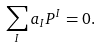Convert formula to latex. <formula><loc_0><loc_0><loc_500><loc_500>\sum _ { I } a _ { I } P ^ { I } = 0 .</formula> 